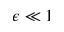Convert formula to latex. <formula><loc_0><loc_0><loc_500><loc_500>\epsilon \ll 1</formula> 